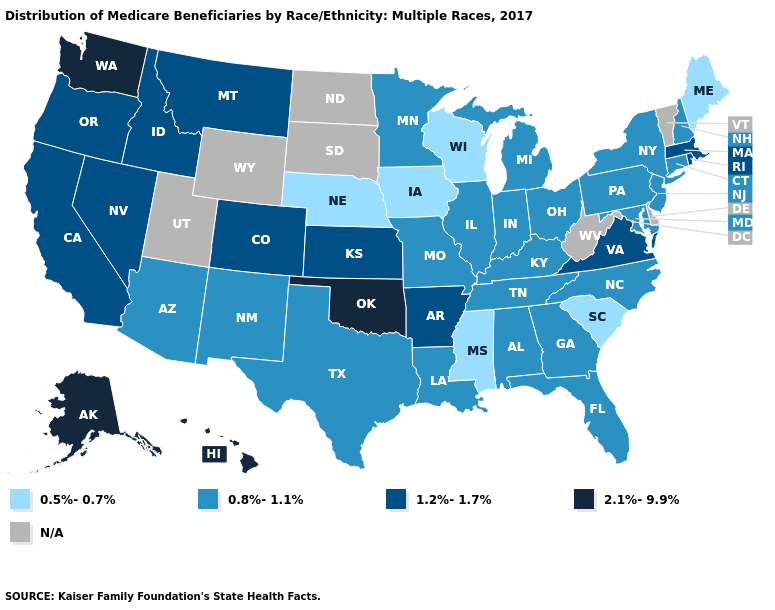What is the value of Kentucky?
Give a very brief answer. 0.8%-1.1%. Among the states that border Wyoming , does Colorado have the highest value?
Answer briefly. Yes. Does Maine have the lowest value in the USA?
Be succinct. Yes. What is the lowest value in the Northeast?
Short answer required. 0.5%-0.7%. What is the value of Washington?
Give a very brief answer. 2.1%-9.9%. What is the value of Alabama?
Keep it brief. 0.8%-1.1%. What is the lowest value in the West?
Give a very brief answer. 0.8%-1.1%. Among the states that border Arkansas , which have the lowest value?
Write a very short answer. Mississippi. Which states have the lowest value in the USA?
Keep it brief. Iowa, Maine, Mississippi, Nebraska, South Carolina, Wisconsin. Which states have the lowest value in the USA?
Write a very short answer. Iowa, Maine, Mississippi, Nebraska, South Carolina, Wisconsin. What is the lowest value in the USA?
Quick response, please. 0.5%-0.7%. Which states have the lowest value in the USA?
Answer briefly. Iowa, Maine, Mississippi, Nebraska, South Carolina, Wisconsin. Name the states that have a value in the range N/A?
Be succinct. Delaware, North Dakota, South Dakota, Utah, Vermont, West Virginia, Wyoming. Which states have the lowest value in the South?
Give a very brief answer. Mississippi, South Carolina. 